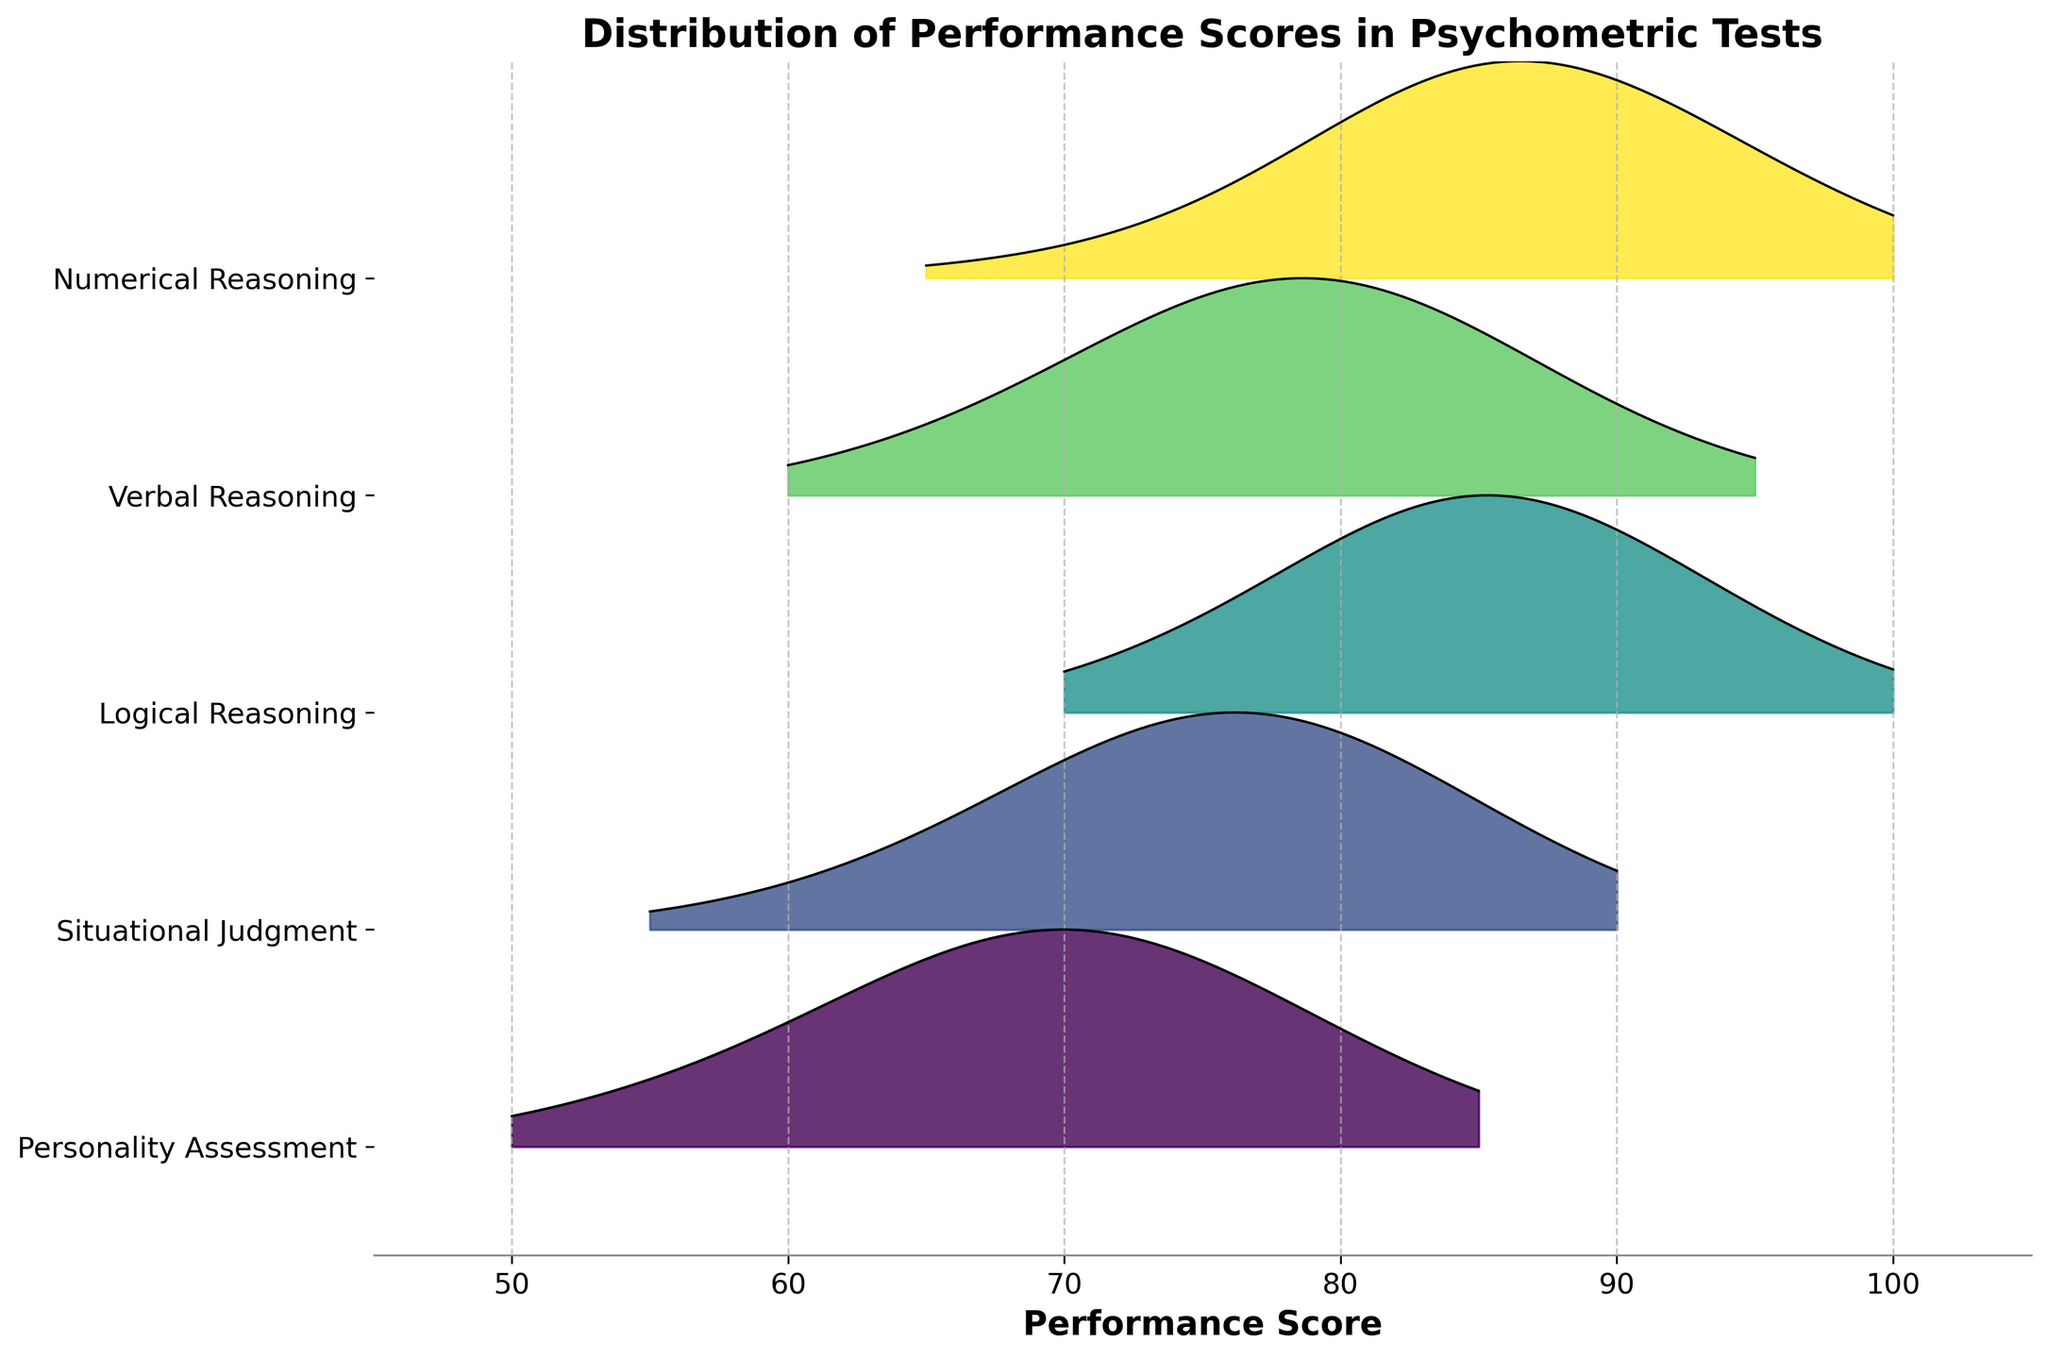What is the title of the figure? The figure's title can be seen at the top of the plot.
Answer: Distribution of Performance Scores in Psychometric Tests What is the range of Performance Scores shown on the x-axis? The x-axis displays the range of Performance Scores, which can be read from the minimum to the maximum value on the axis.
Answer: 45 to 105 How many distinct test sections are displayed in the plot? The different y-tick labels represent the distinct test sections. They are positioned along the y-axis.
Answer: 5 Which test section appears to have the highest peak in terms of frequency? The test section with the highest peak frequency can be identified by finding the section whose ridgeline extends the furthest vertically.
Answer: Logical Reasoning What is the most common performance score range for the Verbal Reasoning section? The area under the curve for Verbal Reasoning with the highest frequency represents the most common performance score range.
Answer: 75-80 Compare the peak frequencies for Numerical Reasoning and Personality Assessment. Which one is higher? Comparing the heights of the peaks for Numerical Reasoning and Personality Assessment on the plot helps determine which section has the higher peak frequency.
Answer: Numerical Reasoning In which performance score range does the Situational Judgment section have the highest frequency? Observe the peak(s) of the curve for the Situational Judgment section and note the corresponding range on the x-axis.
Answer: 70-75 Between the Verbal Reasoning and Logical Reasoning sections, which score has a higher frequency at 85? Look at the heights of the ridgelines for both Verbal Reasoning and Logical Reasoning at the score of 85 to compare their frequencies.
Answer: Logical Reasoning Which section has the lowest peak frequency, and what is the approximate score at that peak? Identify the section whose highest peak is the smallest among all curves and note the performance score where this peak occurs.
Answer: Personality Assessment at 70 Calculate the average peak score for the Situational Judgment and Personality Assessment sections. Determine the peak scores for both sections, then calculate the average of those two peak scores. Situational Judgment peaks around 72.5, and Personality Assessment peaks around 70.
Answer: 71.25 